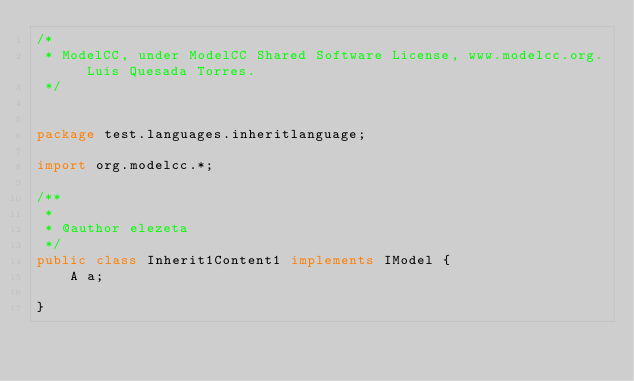Convert code to text. <code><loc_0><loc_0><loc_500><loc_500><_Java_>/*
 * ModelCC, under ModelCC Shared Software License, www.modelcc.org. Luis Quesada Torres.
 */


package test.languages.inheritlanguage;

import org.modelcc.*;

/**
 *
 * @author elezeta
 */
public class Inherit1Content1 implements IModel {
	A a;
	
}
</code> 